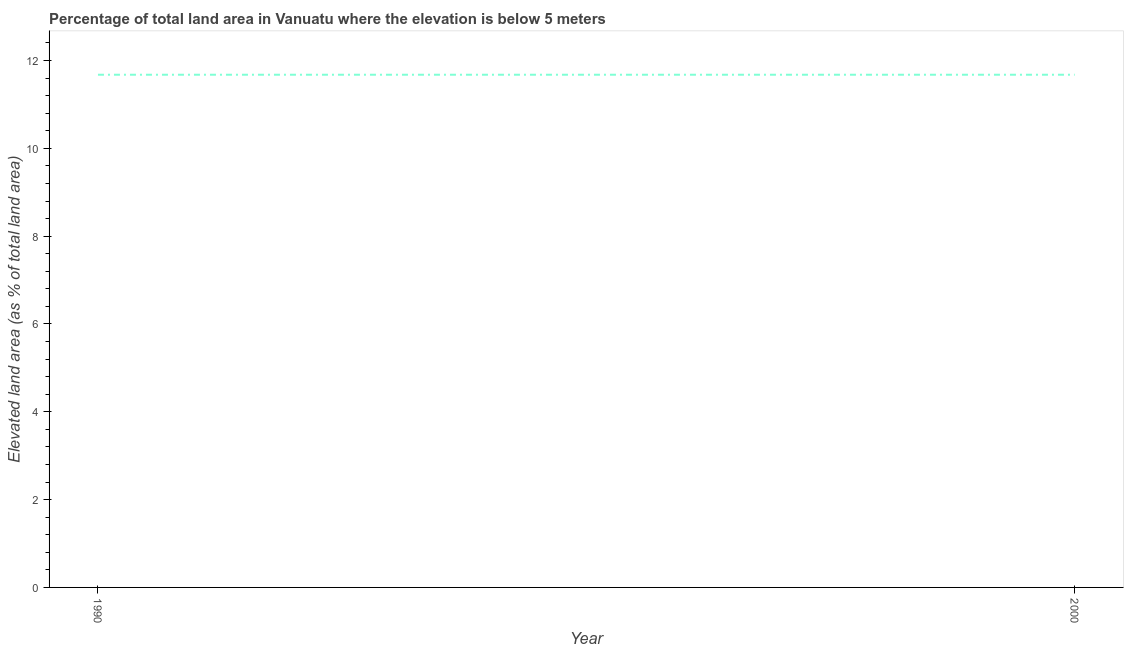What is the total elevated land area in 2000?
Your answer should be very brief. 11.68. Across all years, what is the maximum total elevated land area?
Offer a terse response. 11.68. Across all years, what is the minimum total elevated land area?
Your response must be concise. 11.68. In which year was the total elevated land area minimum?
Provide a short and direct response. 1990. What is the sum of the total elevated land area?
Make the answer very short. 23.35. What is the difference between the total elevated land area in 1990 and 2000?
Offer a terse response. 0. What is the average total elevated land area per year?
Give a very brief answer. 11.68. What is the median total elevated land area?
Your answer should be very brief. 11.68. In how many years, is the total elevated land area greater than 2.8 %?
Your answer should be very brief. 2. Do a majority of the years between 1990 and 2000 (inclusive) have total elevated land area greater than 6.4 %?
Your answer should be compact. Yes. In how many years, is the total elevated land area greater than the average total elevated land area taken over all years?
Your response must be concise. 0. How many years are there in the graph?
Your answer should be compact. 2. What is the difference between two consecutive major ticks on the Y-axis?
Your answer should be very brief. 2. Are the values on the major ticks of Y-axis written in scientific E-notation?
Offer a terse response. No. Does the graph contain grids?
Keep it short and to the point. No. What is the title of the graph?
Your answer should be very brief. Percentage of total land area in Vanuatu where the elevation is below 5 meters. What is the label or title of the X-axis?
Keep it short and to the point. Year. What is the label or title of the Y-axis?
Provide a succinct answer. Elevated land area (as % of total land area). What is the Elevated land area (as % of total land area) of 1990?
Provide a short and direct response. 11.68. What is the Elevated land area (as % of total land area) of 2000?
Ensure brevity in your answer.  11.68. What is the ratio of the Elevated land area (as % of total land area) in 1990 to that in 2000?
Offer a terse response. 1. 